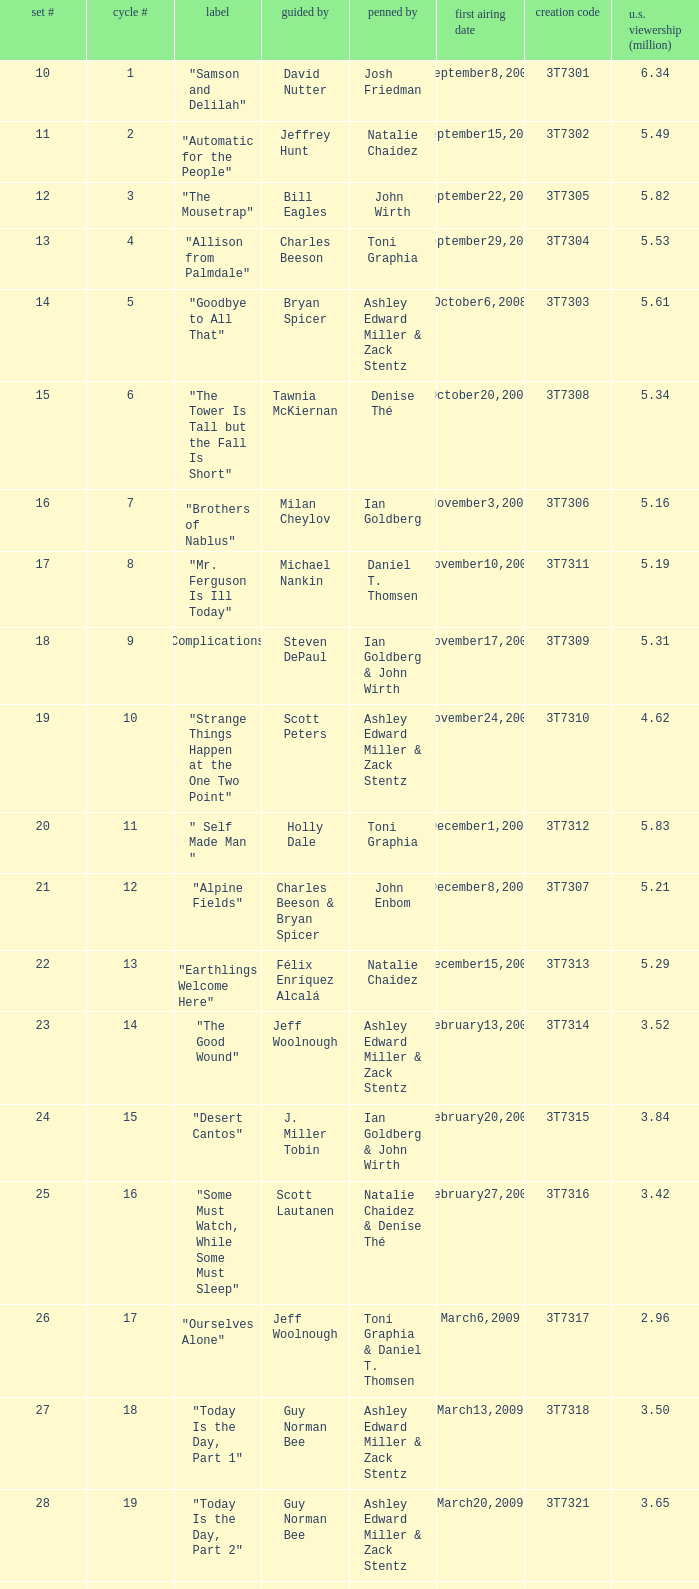Which episode number drew in 3.35 million viewers in the United States? 1.0. 